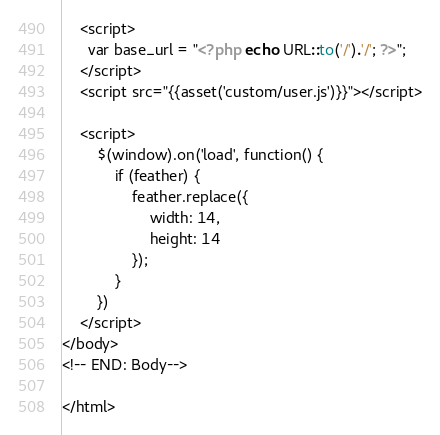<code> <loc_0><loc_0><loc_500><loc_500><_PHP_>    <script>
      var base_url = "<?php echo URL::to('/').'/'; ?>";
    </script>
    <script src="{{asset('custom/user.js')}}"></script>

    <script>
        $(window).on('load', function() {
            if (feather) {
                feather.replace({
                    width: 14,
                    height: 14
                });
            }
        })
    </script>
</body>
<!-- END: Body-->

</html></code> 